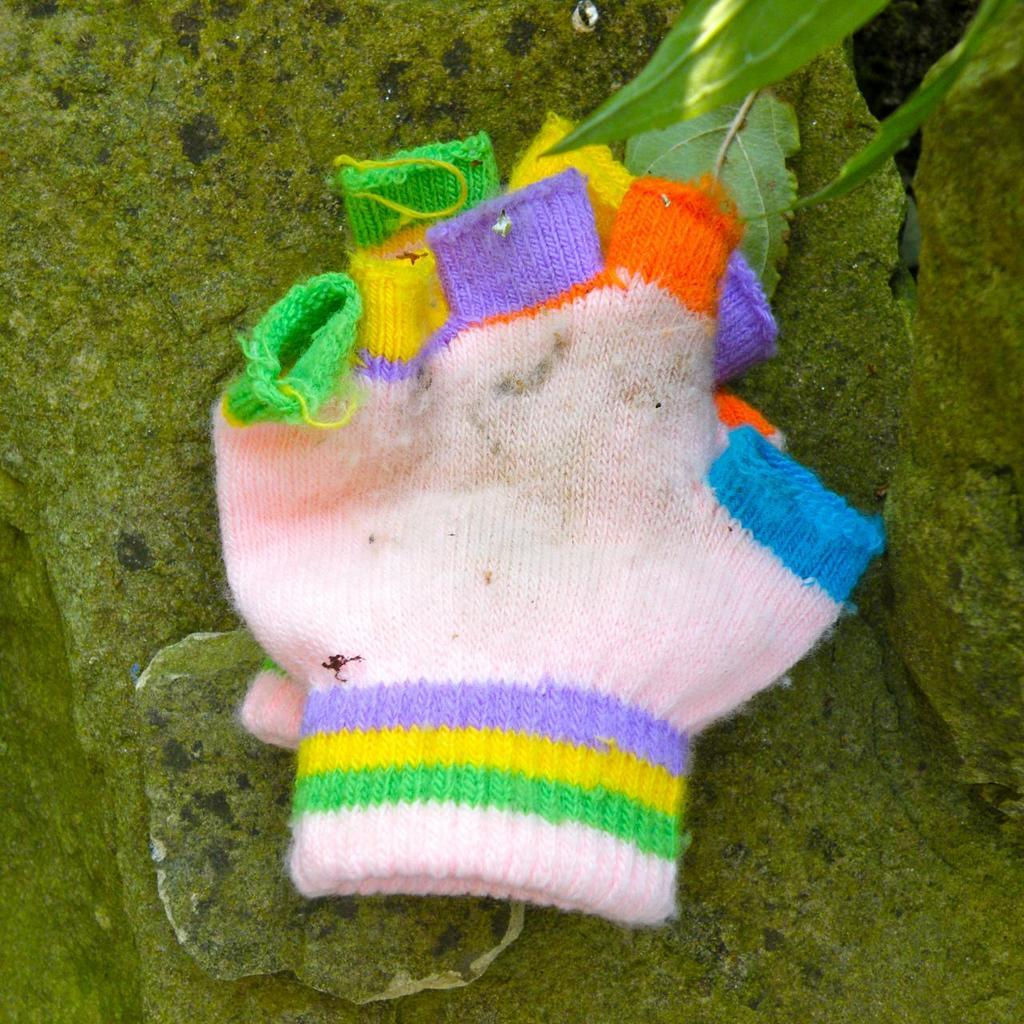What is the color of the surface in the image? The surface in the image is green. What objects are placed on the green surface? There are two colorful gloves on the green surface. What else can be seen in the image besides the gloves and green surface? There are leaves in the image. What type of railway is visible in the image? There is no railway present in the image. How many arms are visible in the image? There are no arms visible in the image. 